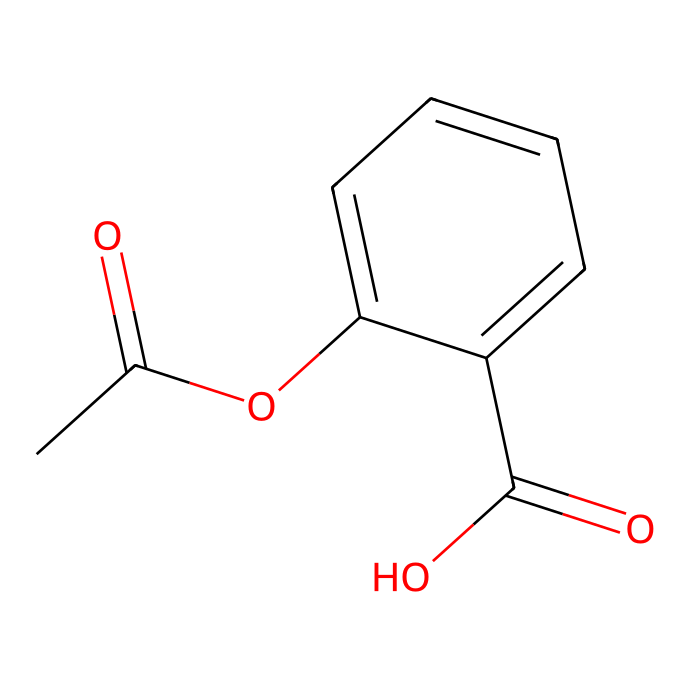What is the molecular formula of acetylsalicylic acid? To derive the molecular formula, we can count the atoms present in the chemical structure represented by the SMILES. The atoms include: 9 Carbon (C), 8 Hydrogen (H), 4 Oxygen (O). Therefore, the molecular formula is C9H8O4.
Answer: C9H8O4 How many rings are present in acetylsalicylic acid? From the chemical structure, we can identify that there is one distinct aromatic ring in addition to the carbon chain. The carbon atoms in the ring structure indicate a continuous cycle, hence there is one ring.
Answer: 1 What functional groups are present in acetylsalicylic acid? Analyzing the structure, we can identify two major functional groups: the acetate group (ester) represented by the -OC(=O) structure and the carboxylic acid group (-C(=O)O). Therefore, there are two functional groups present.
Answer: two Does acetylsalicylic acid contain a carbonyl group? Looking at the structure, we can identify the presence of carbonyl groups (C=O) found in both the carboxylic acid and acetate parts of the molecule. Thus, we conclude that it does indeed contain carbonyl groups.
Answer: yes What type of compound is acetylsalicylic acid classified as? Given that acetylsalicylic acid has a benzene ring and additional functional groups, it is classified as an aromatic compound. The presence of the aromatic ring is a defining characteristic of this classification.
Answer: aromatic 